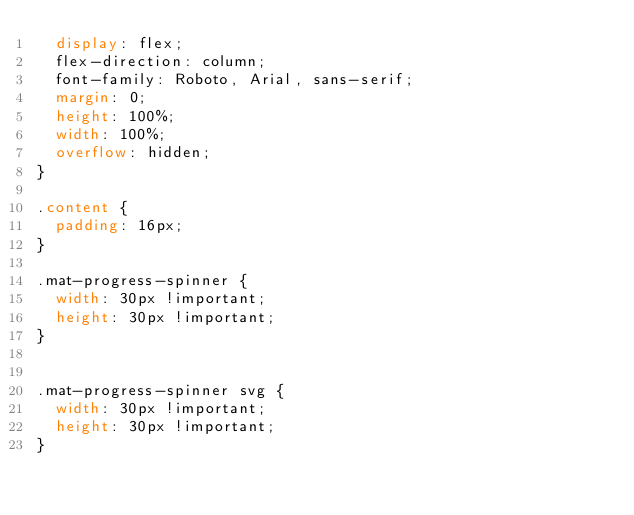<code> <loc_0><loc_0><loc_500><loc_500><_CSS_>  display: flex;
  flex-direction: column;
  font-family: Roboto, Arial, sans-serif;
  margin: 0;
  height: 100%;
  width: 100%;
  overflow: hidden;
}

.content {
  padding: 16px;
}

.mat-progress-spinner {
  width: 30px !important;
  height: 30px !important;
}


.mat-progress-spinner svg {
  width: 30px !important;
  height: 30px !important;
}
</code> 